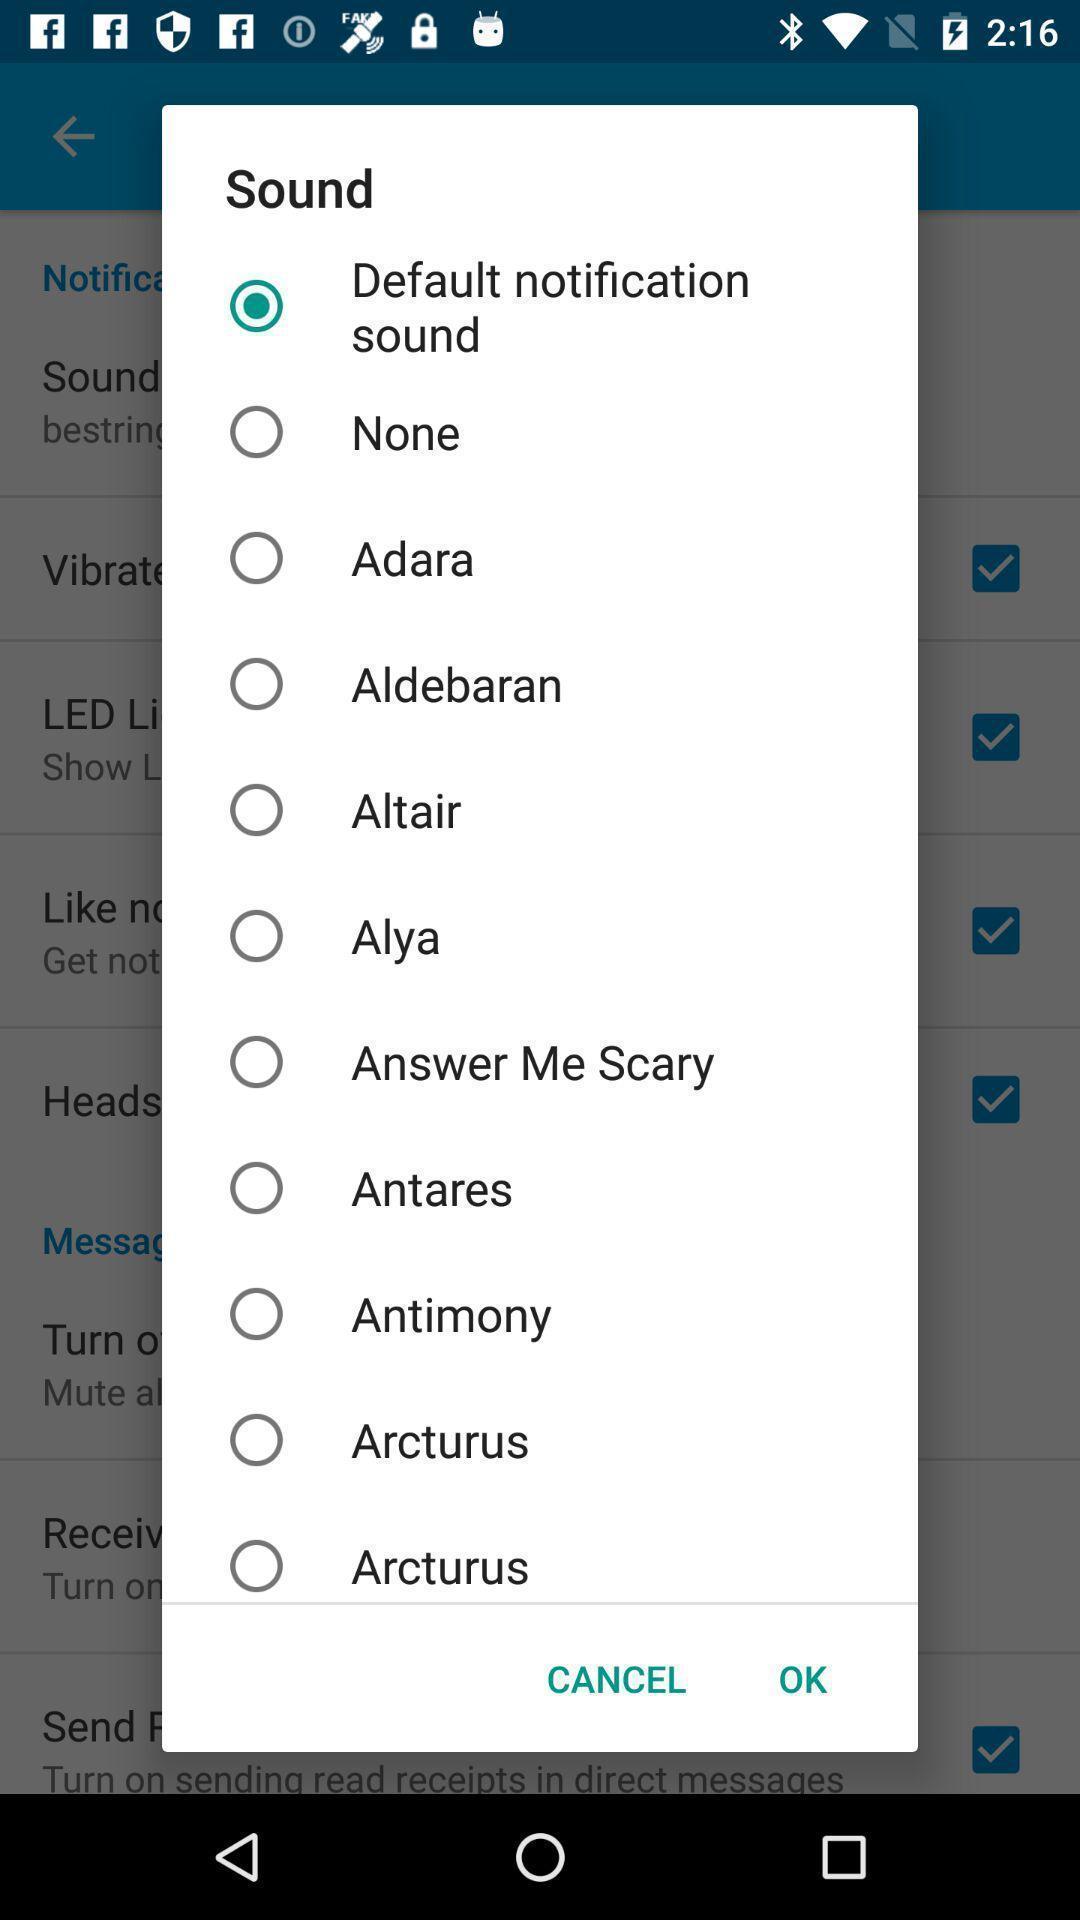What can you discern from this picture? Pop-up with selection options in a messaging app. 